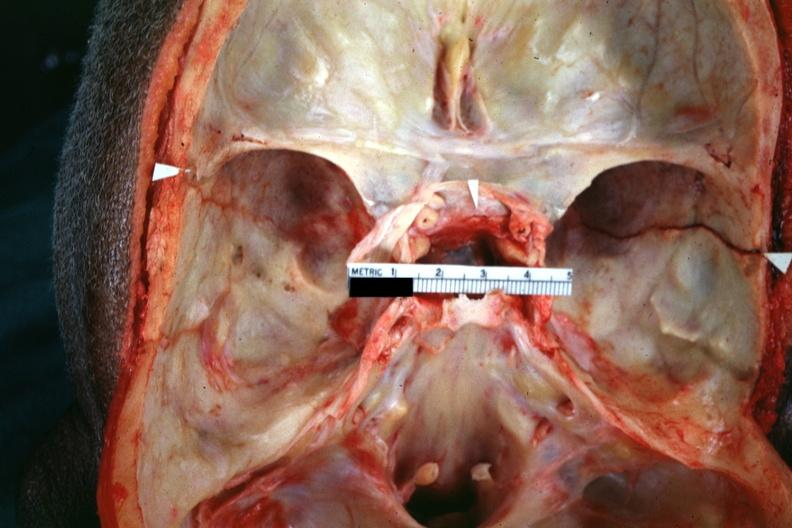s basilar skull fracture present?
Answer the question using a single word or phrase. Yes 